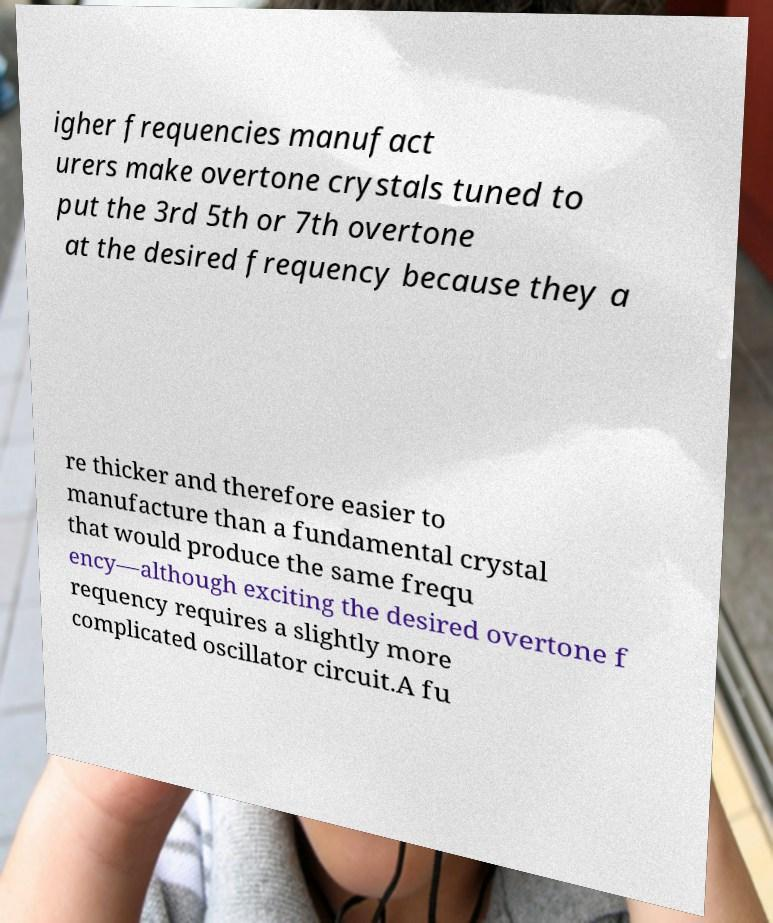Can you accurately transcribe the text from the provided image for me? igher frequencies manufact urers make overtone crystals tuned to put the 3rd 5th or 7th overtone at the desired frequency because they a re thicker and therefore easier to manufacture than a fundamental crystal that would produce the same frequ ency—although exciting the desired overtone f requency requires a slightly more complicated oscillator circuit.A fu 